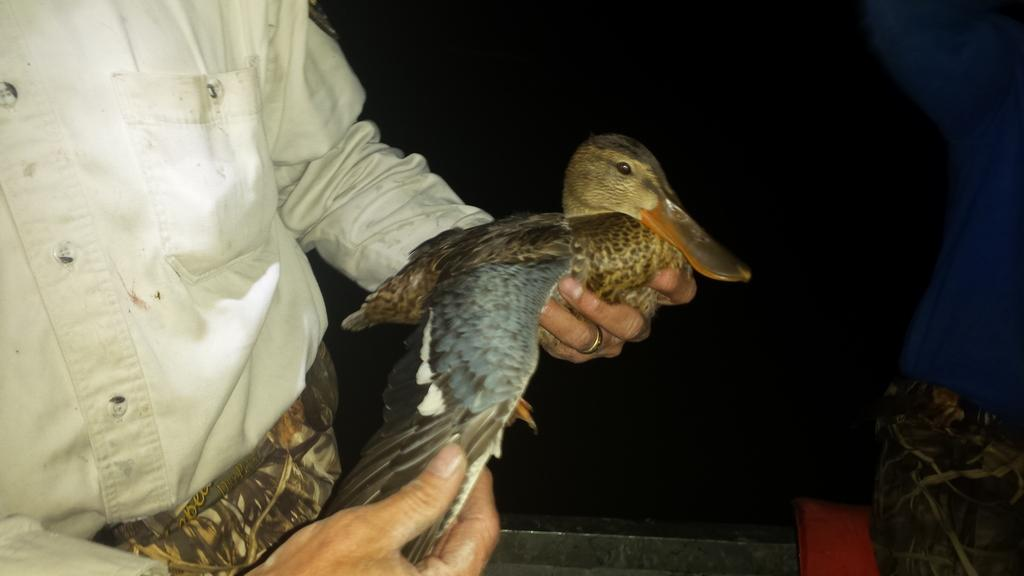What is the main subject of the image? There is a person in the image. What is the person holding in the image? The person is holding a bird. What color is the background of the image? The background of the image is black. What type of pain can be seen on the person's face in the image? There is no indication of pain on the person's face in the image. On which side of the person is the bird located? The image does not provide enough information to determine which side of the person the bird is located. 